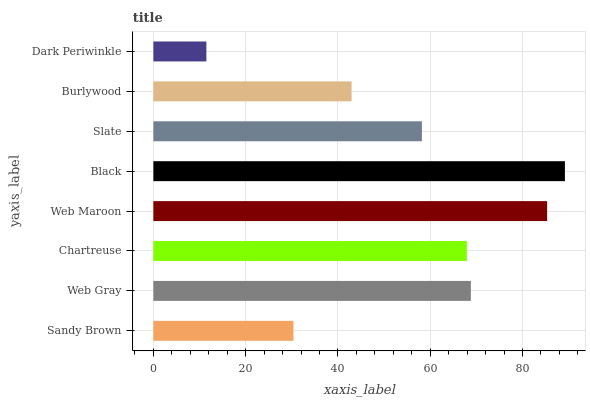Is Dark Periwinkle the minimum?
Answer yes or no. Yes. Is Black the maximum?
Answer yes or no. Yes. Is Web Gray the minimum?
Answer yes or no. No. Is Web Gray the maximum?
Answer yes or no. No. Is Web Gray greater than Sandy Brown?
Answer yes or no. Yes. Is Sandy Brown less than Web Gray?
Answer yes or no. Yes. Is Sandy Brown greater than Web Gray?
Answer yes or no. No. Is Web Gray less than Sandy Brown?
Answer yes or no. No. Is Chartreuse the high median?
Answer yes or no. Yes. Is Slate the low median?
Answer yes or no. Yes. Is Slate the high median?
Answer yes or no. No. Is Burlywood the low median?
Answer yes or no. No. 